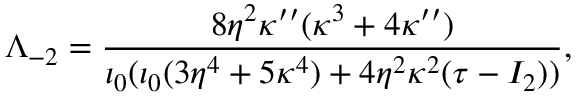Convert formula to latex. <formula><loc_0><loc_0><loc_500><loc_500>\Lambda _ { - 2 } = \frac { 8 \eta ^ { 2 } \kappa ^ { \prime \prime } ( \kappa ^ { 3 } + 4 \kappa ^ { \prime \prime } ) } { \iota _ { 0 } ( \iota _ { 0 } ( 3 \eta ^ { 4 } + 5 \kappa ^ { 4 } ) + 4 \eta ^ { 2 } \kappa ^ { 2 } ( \tau - I _ { 2 } ) ) } ,</formula> 